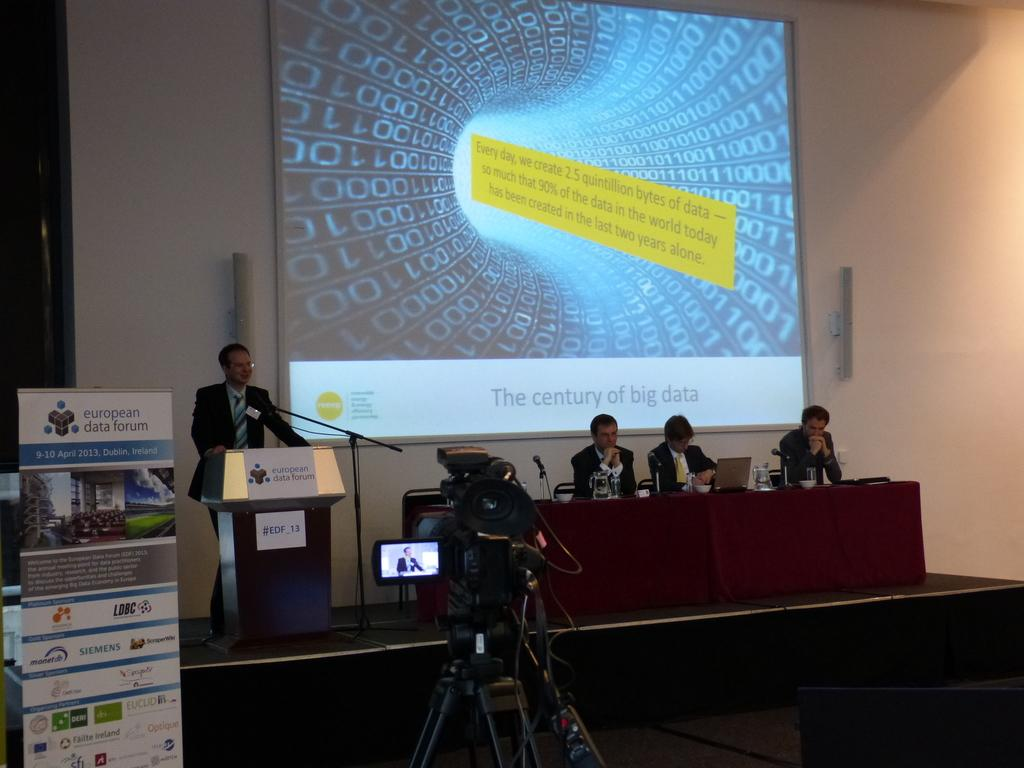<image>
Write a terse but informative summary of the picture. A presentation screen behind the presenter showing the century of big data. 